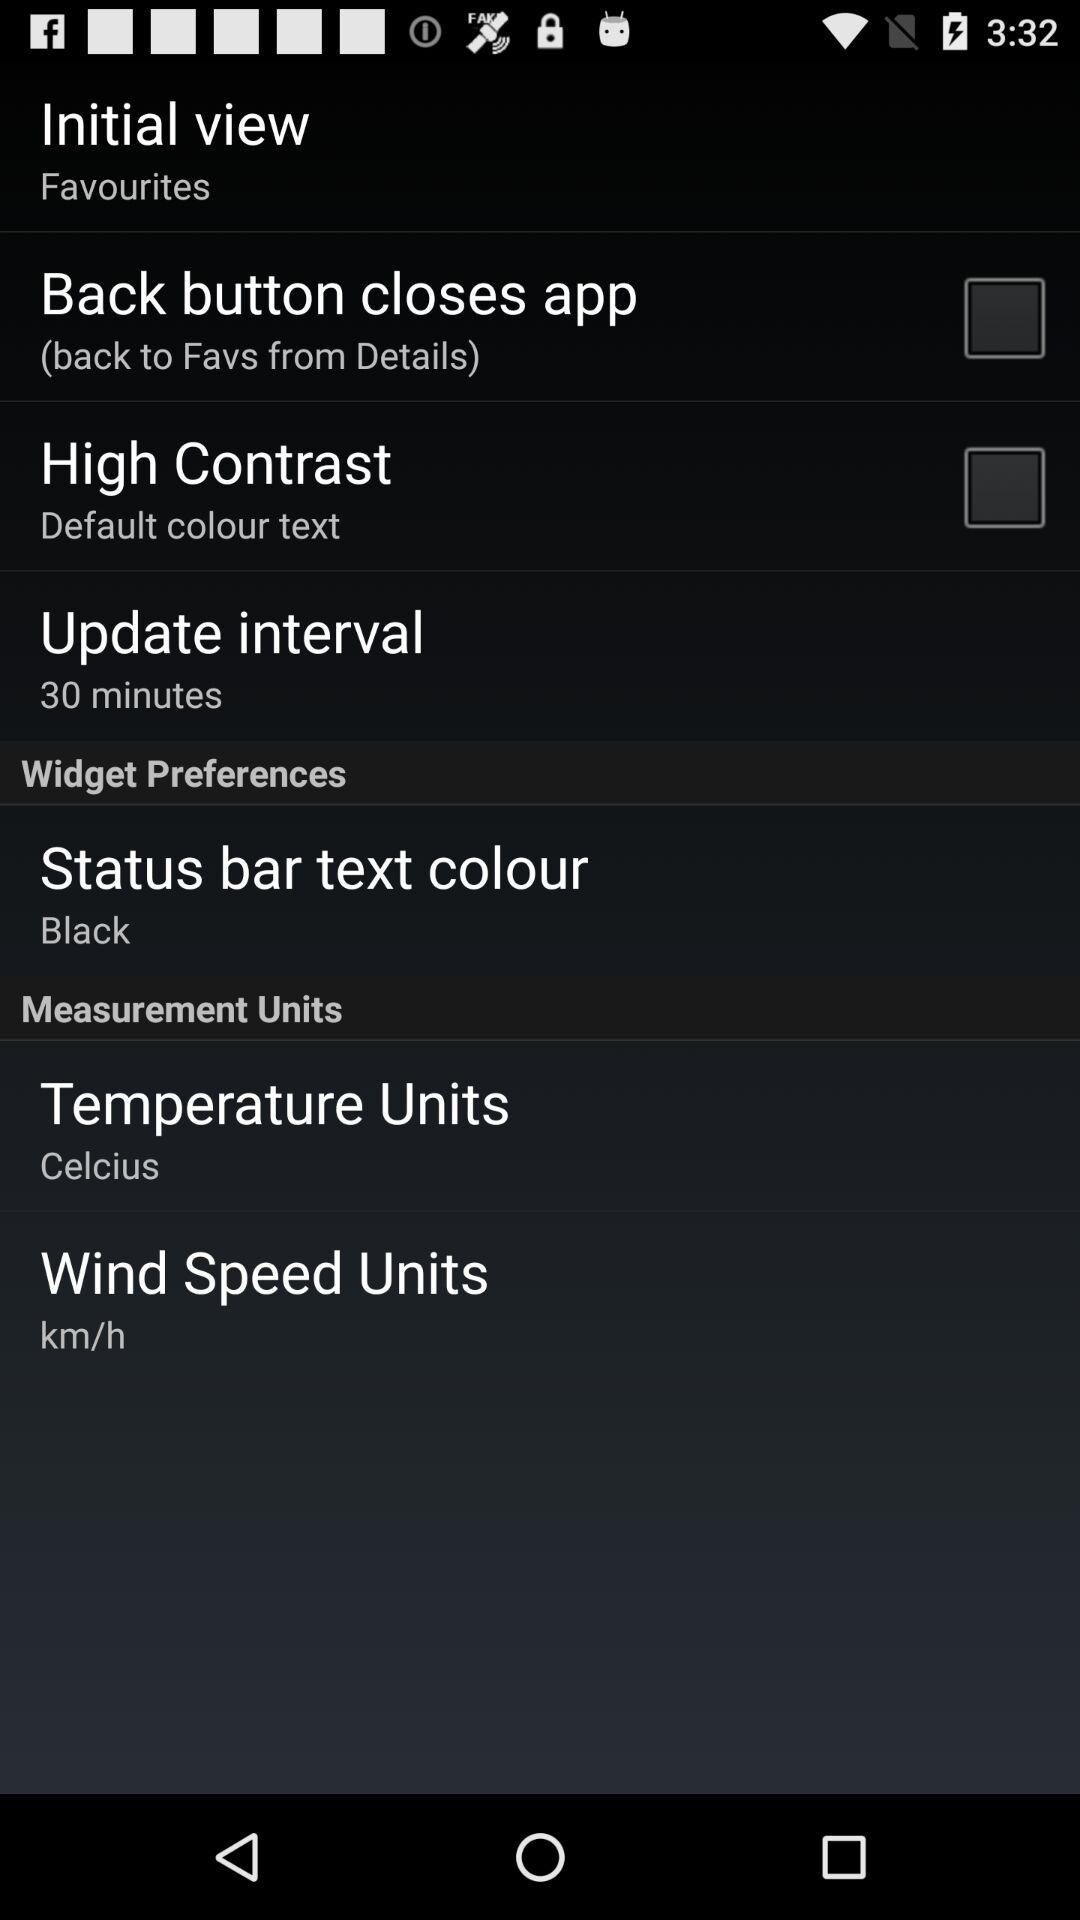What is the update interval? The update interval is 30 minutes. 